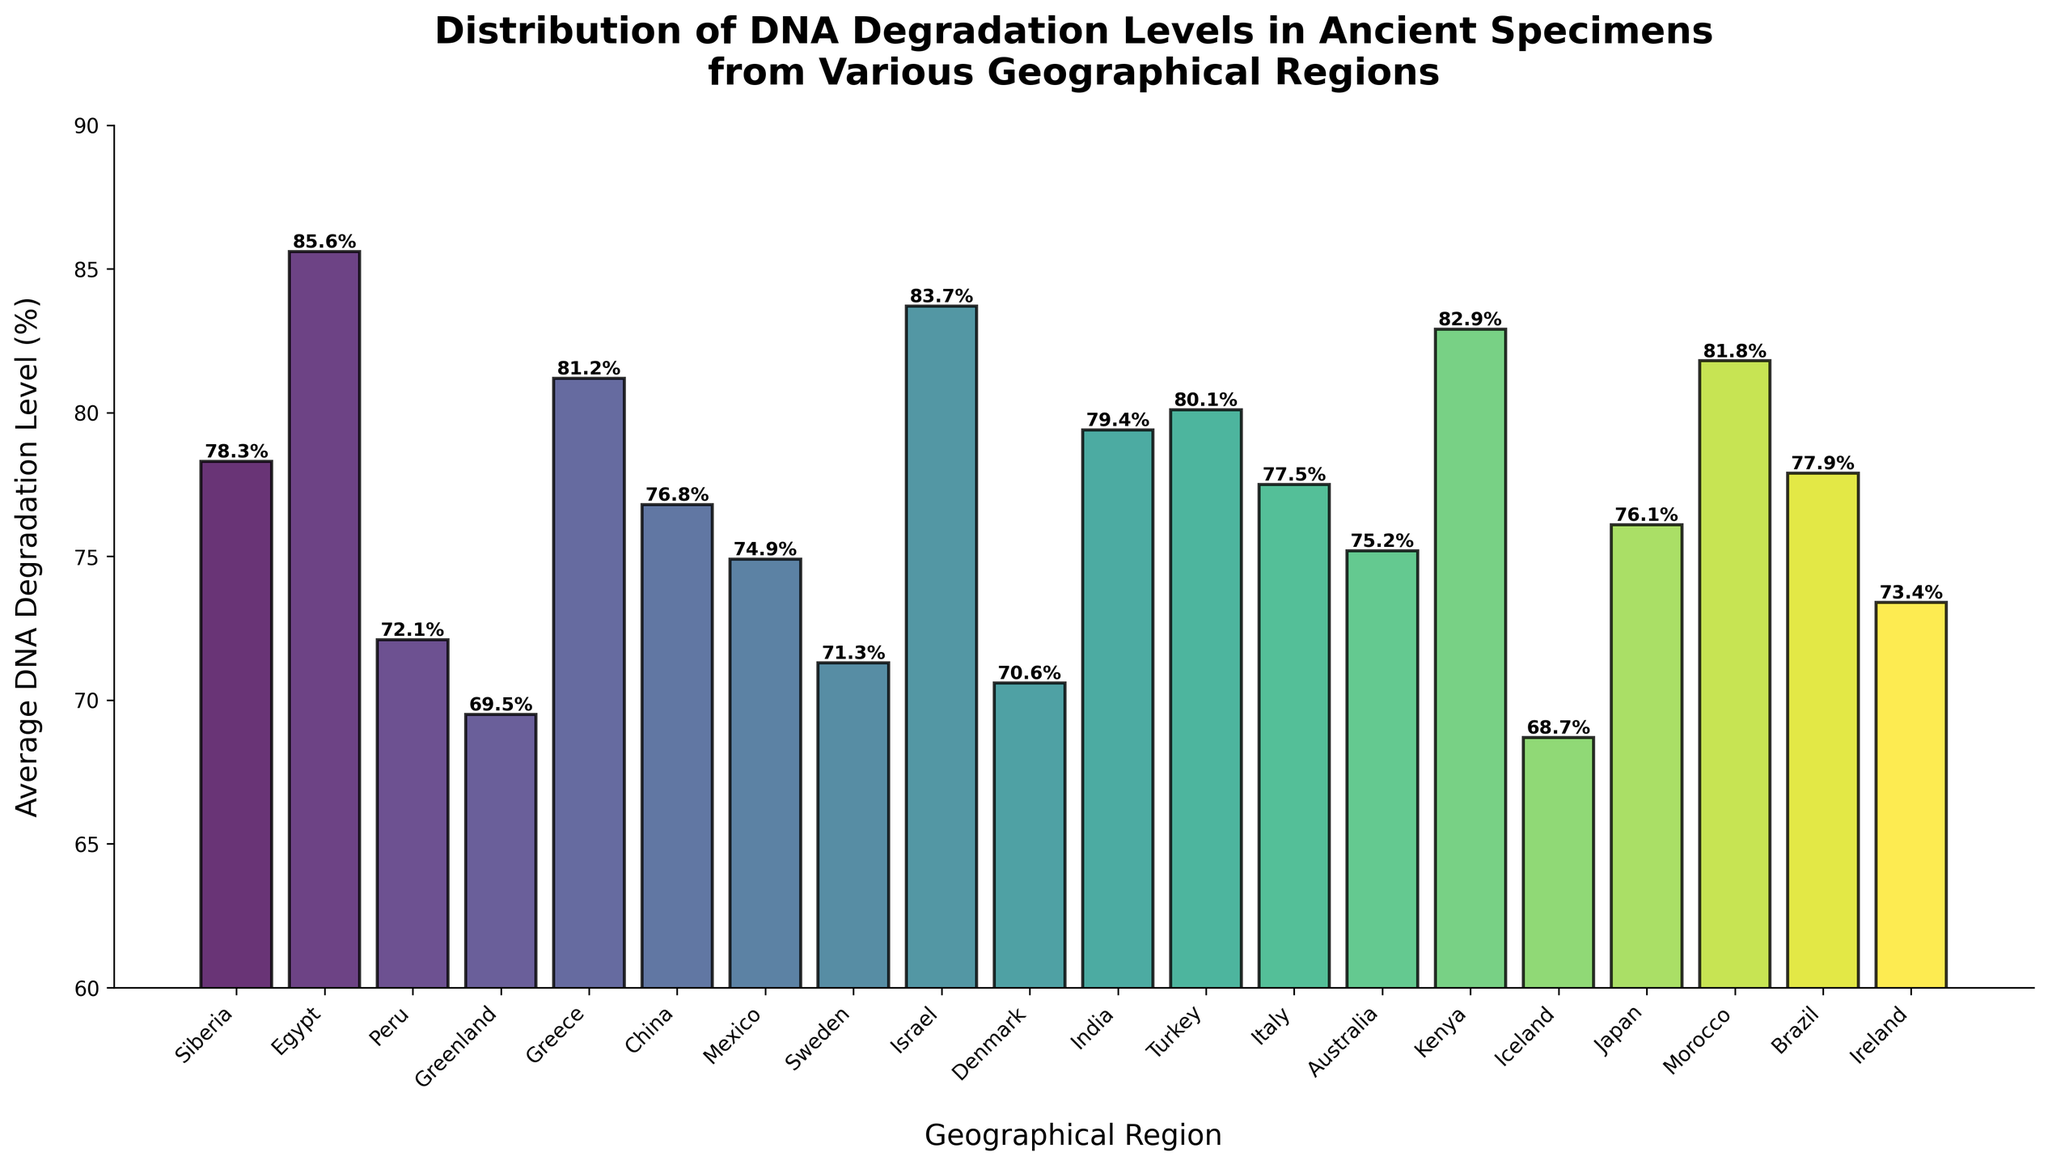What region has the highest average DNA degradation level? By visually inspecting the heights of the bars, the highest bar represents Egypt. This indicates that Egypt has the highest average DNA degradation level among the regions.
Answer: Egypt Which region has the lowest average DNA degradation level? By visually inspecting the heights of the bars, the lowest bar represents Iceland. This indicates that Iceland has the lowest average DNA degradation level among the regions.
Answer: Iceland What's the difference in average DNA degradation levels between Egypt and Peru? Locate the bars for Egypt and Peru, which have average degradation levels of 85.6% and 72.1%, respectively. Subtract Peru's level from Egypt's level: 85.6 - 72.1 = 13.5.
Answer: 13.5 Which regions have average DNA degradation levels greater than 80%? Visually inspect the bars and identify those with heights corresponding to values above 80%. The regions are Egypt, Greece, Israel, Turkey, Kenya, and Morocco.
Answer: Egypt, Greece, Israel, Turkey, Kenya, Morocco What is the average DNA degradation level for the regions in South America? Identify the South American regions (Peru and Brazil). Their degradation levels are 72.1% and 77.9%, respectively. Calculate the average: (72.1 + 77.9) / 2 = 150.0 / 2 = 75.0.
Answer: 75.0 Which region in Europe has the highest average DNA degradation level? Visually inspect the bars representing European regions. The highest among these is Greece with an average DNA degradation level of 81.2%.
Answer: Greece How many regions have an average DNA degradation level between 70% and 80%? Visually inspect the bars and count those between the 70% and 80% marks. The regions are Peru, Greenland, China, Mexico, Sweden, Denmark, India, Italy, Australia, and Ireland, totaling 10 regions.
Answer: 10 What's the combined average DNA degradation level of regions in Asia? Identify the Asian regions: China, India, Israel, Turkey, and Japan. Sum their degradation levels and divide by the number of regions: (76.8 + 79.4 + 83.7 + 80.1 + 76.1) / 5 = 396.1 / 5 = 79.22.
Answer: 79.22 Which region has a degradation level closest to the average level among all regions? Calculate the overall average degradation level first: Sum all values and divide by 20. The total is 1512.2. So, 1512.2 / 20 = 75.61. Greenland, with 75.2, is the closest.
Answer: Greenland 